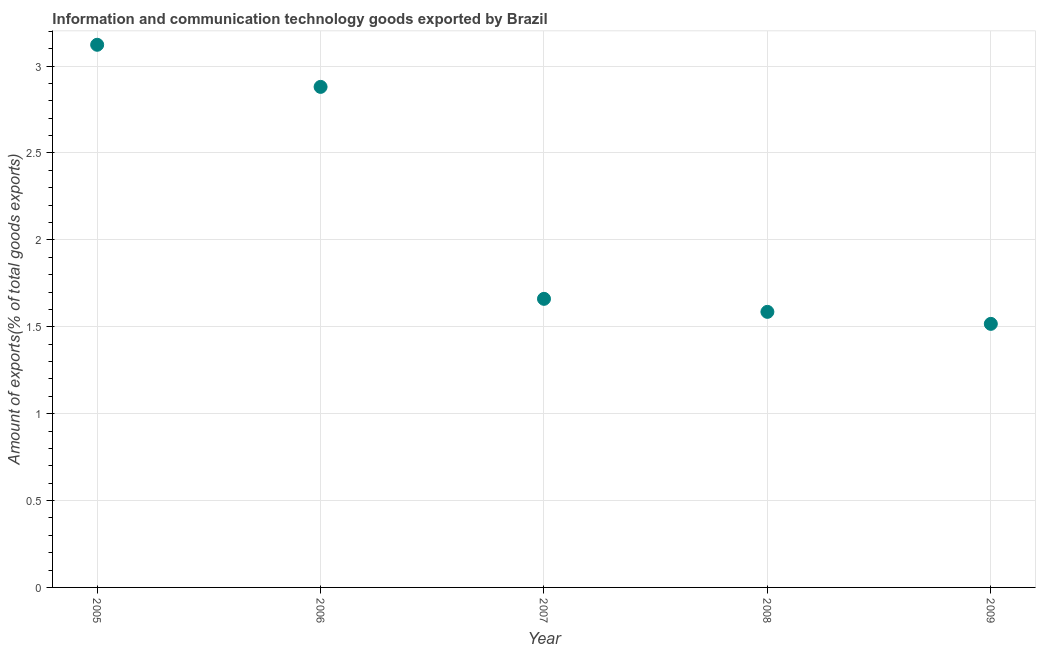What is the amount of ict goods exports in 2005?
Provide a succinct answer. 3.12. Across all years, what is the maximum amount of ict goods exports?
Make the answer very short. 3.12. Across all years, what is the minimum amount of ict goods exports?
Make the answer very short. 1.52. In which year was the amount of ict goods exports minimum?
Make the answer very short. 2009. What is the sum of the amount of ict goods exports?
Give a very brief answer. 10.77. What is the difference between the amount of ict goods exports in 2006 and 2009?
Your response must be concise. 1.36. What is the average amount of ict goods exports per year?
Make the answer very short. 2.15. What is the median amount of ict goods exports?
Your response must be concise. 1.66. In how many years, is the amount of ict goods exports greater than 1.3 %?
Make the answer very short. 5. What is the ratio of the amount of ict goods exports in 2007 to that in 2008?
Keep it short and to the point. 1.05. What is the difference between the highest and the second highest amount of ict goods exports?
Ensure brevity in your answer.  0.24. What is the difference between the highest and the lowest amount of ict goods exports?
Your response must be concise. 1.61. Does the amount of ict goods exports monotonically increase over the years?
Ensure brevity in your answer.  No. How many dotlines are there?
Provide a succinct answer. 1. How many years are there in the graph?
Provide a short and direct response. 5. Are the values on the major ticks of Y-axis written in scientific E-notation?
Ensure brevity in your answer.  No. Does the graph contain grids?
Your answer should be compact. Yes. What is the title of the graph?
Your response must be concise. Information and communication technology goods exported by Brazil. What is the label or title of the Y-axis?
Your response must be concise. Amount of exports(% of total goods exports). What is the Amount of exports(% of total goods exports) in 2005?
Provide a short and direct response. 3.12. What is the Amount of exports(% of total goods exports) in 2006?
Your answer should be very brief. 2.88. What is the Amount of exports(% of total goods exports) in 2007?
Offer a terse response. 1.66. What is the Amount of exports(% of total goods exports) in 2008?
Provide a succinct answer. 1.59. What is the Amount of exports(% of total goods exports) in 2009?
Offer a very short reply. 1.52. What is the difference between the Amount of exports(% of total goods exports) in 2005 and 2006?
Your response must be concise. 0.24. What is the difference between the Amount of exports(% of total goods exports) in 2005 and 2007?
Ensure brevity in your answer.  1.46. What is the difference between the Amount of exports(% of total goods exports) in 2005 and 2008?
Keep it short and to the point. 1.54. What is the difference between the Amount of exports(% of total goods exports) in 2005 and 2009?
Your answer should be very brief. 1.61. What is the difference between the Amount of exports(% of total goods exports) in 2006 and 2007?
Provide a succinct answer. 1.22. What is the difference between the Amount of exports(% of total goods exports) in 2006 and 2008?
Your answer should be compact. 1.29. What is the difference between the Amount of exports(% of total goods exports) in 2006 and 2009?
Provide a short and direct response. 1.36. What is the difference between the Amount of exports(% of total goods exports) in 2007 and 2008?
Keep it short and to the point. 0.07. What is the difference between the Amount of exports(% of total goods exports) in 2007 and 2009?
Ensure brevity in your answer.  0.14. What is the difference between the Amount of exports(% of total goods exports) in 2008 and 2009?
Your answer should be compact. 0.07. What is the ratio of the Amount of exports(% of total goods exports) in 2005 to that in 2006?
Offer a very short reply. 1.08. What is the ratio of the Amount of exports(% of total goods exports) in 2005 to that in 2007?
Keep it short and to the point. 1.88. What is the ratio of the Amount of exports(% of total goods exports) in 2005 to that in 2008?
Make the answer very short. 1.97. What is the ratio of the Amount of exports(% of total goods exports) in 2005 to that in 2009?
Keep it short and to the point. 2.06. What is the ratio of the Amount of exports(% of total goods exports) in 2006 to that in 2007?
Your answer should be compact. 1.73. What is the ratio of the Amount of exports(% of total goods exports) in 2006 to that in 2008?
Provide a short and direct response. 1.82. What is the ratio of the Amount of exports(% of total goods exports) in 2006 to that in 2009?
Your response must be concise. 1.9. What is the ratio of the Amount of exports(% of total goods exports) in 2007 to that in 2008?
Offer a terse response. 1.05. What is the ratio of the Amount of exports(% of total goods exports) in 2007 to that in 2009?
Your answer should be compact. 1.09. What is the ratio of the Amount of exports(% of total goods exports) in 2008 to that in 2009?
Give a very brief answer. 1.05. 